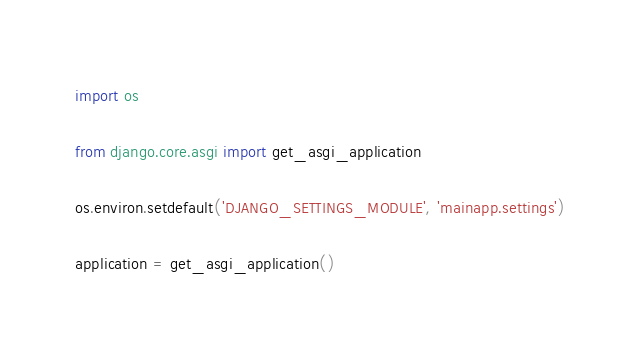<code> <loc_0><loc_0><loc_500><loc_500><_Python_>import os

from django.core.asgi import get_asgi_application

os.environ.setdefault('DJANGO_SETTINGS_MODULE', 'mainapp.settings')

application = get_asgi_application()
</code> 